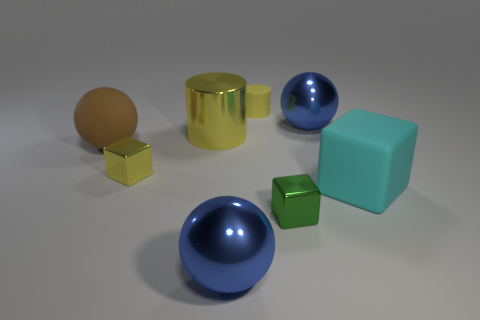Subtract all yellow metal cubes. How many cubes are left? 2 Subtract all yellow blocks. How many blue spheres are left? 2 Add 1 tiny purple metallic balls. How many objects exist? 9 Subtract all green blocks. How many blocks are left? 2 Subtract 1 cubes. How many cubes are left? 2 Subtract all cylinders. How many objects are left? 6 Subtract 0 yellow balls. How many objects are left? 8 Subtract all yellow balls. Subtract all blue blocks. How many balls are left? 3 Subtract all big yellow things. Subtract all green blocks. How many objects are left? 6 Add 8 tiny shiny things. How many tiny shiny things are left? 10 